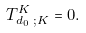<formula> <loc_0><loc_0><loc_500><loc_500>T _ { d _ { 0 } \text { } ; K } ^ { K } = 0 .</formula> 